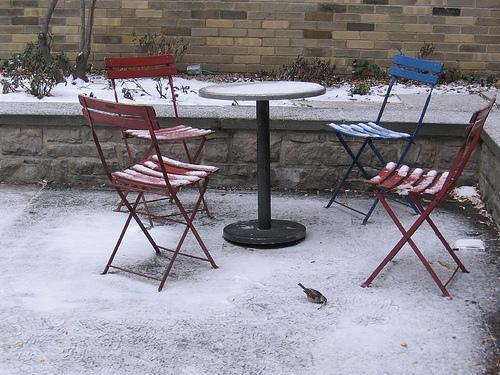How many chairs are there?
Give a very brief answer. 4. How many chairs are red?
Give a very brief answer. 3. How many red chairs are there?
Give a very brief answer. 3. 